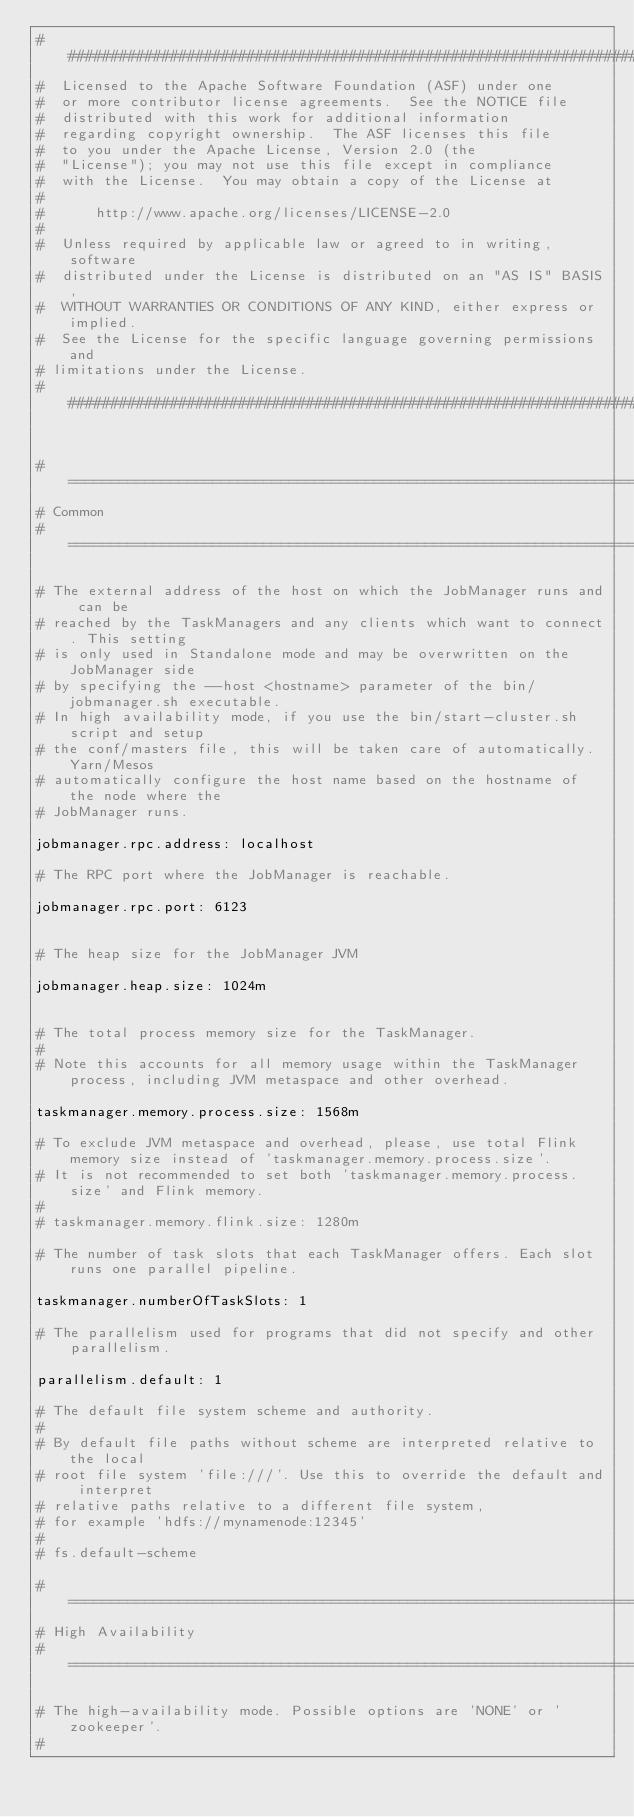<code> <loc_0><loc_0><loc_500><loc_500><_YAML_>################################################################################
#  Licensed to the Apache Software Foundation (ASF) under one
#  or more contributor license agreements.  See the NOTICE file
#  distributed with this work for additional information
#  regarding copyright ownership.  The ASF licenses this file
#  to you under the Apache License, Version 2.0 (the
#  "License"); you may not use this file except in compliance
#  with the License.  You may obtain a copy of the License at
#
#      http://www.apache.org/licenses/LICENSE-2.0
#
#  Unless required by applicable law or agreed to in writing, software
#  distributed under the License is distributed on an "AS IS" BASIS,
#  WITHOUT WARRANTIES OR CONDITIONS OF ANY KIND, either express or implied.
#  See the License for the specific language governing permissions and
# limitations under the License.
################################################################################


#==============================================================================
# Common
#==============================================================================

# The external address of the host on which the JobManager runs and can be
# reached by the TaskManagers and any clients which want to connect. This setting
# is only used in Standalone mode and may be overwritten on the JobManager side
# by specifying the --host <hostname> parameter of the bin/jobmanager.sh executable.
# In high availability mode, if you use the bin/start-cluster.sh script and setup
# the conf/masters file, this will be taken care of automatically. Yarn/Mesos
# automatically configure the host name based on the hostname of the node where the
# JobManager runs.

jobmanager.rpc.address: localhost

# The RPC port where the JobManager is reachable.

jobmanager.rpc.port: 6123


# The heap size for the JobManager JVM

jobmanager.heap.size: 1024m


# The total process memory size for the TaskManager.
#
# Note this accounts for all memory usage within the TaskManager process, including JVM metaspace and other overhead.

taskmanager.memory.process.size: 1568m

# To exclude JVM metaspace and overhead, please, use total Flink memory size instead of 'taskmanager.memory.process.size'.
# It is not recommended to set both 'taskmanager.memory.process.size' and Flink memory.
#
# taskmanager.memory.flink.size: 1280m

# The number of task slots that each TaskManager offers. Each slot runs one parallel pipeline.

taskmanager.numberOfTaskSlots: 1

# The parallelism used for programs that did not specify and other parallelism.

parallelism.default: 1

# The default file system scheme and authority.
# 
# By default file paths without scheme are interpreted relative to the local
# root file system 'file:///'. Use this to override the default and interpret
# relative paths relative to a different file system,
# for example 'hdfs://mynamenode:12345'
#
# fs.default-scheme

#==============================================================================
# High Availability
#==============================================================================

# The high-availability mode. Possible options are 'NONE' or 'zookeeper'.
#</code> 